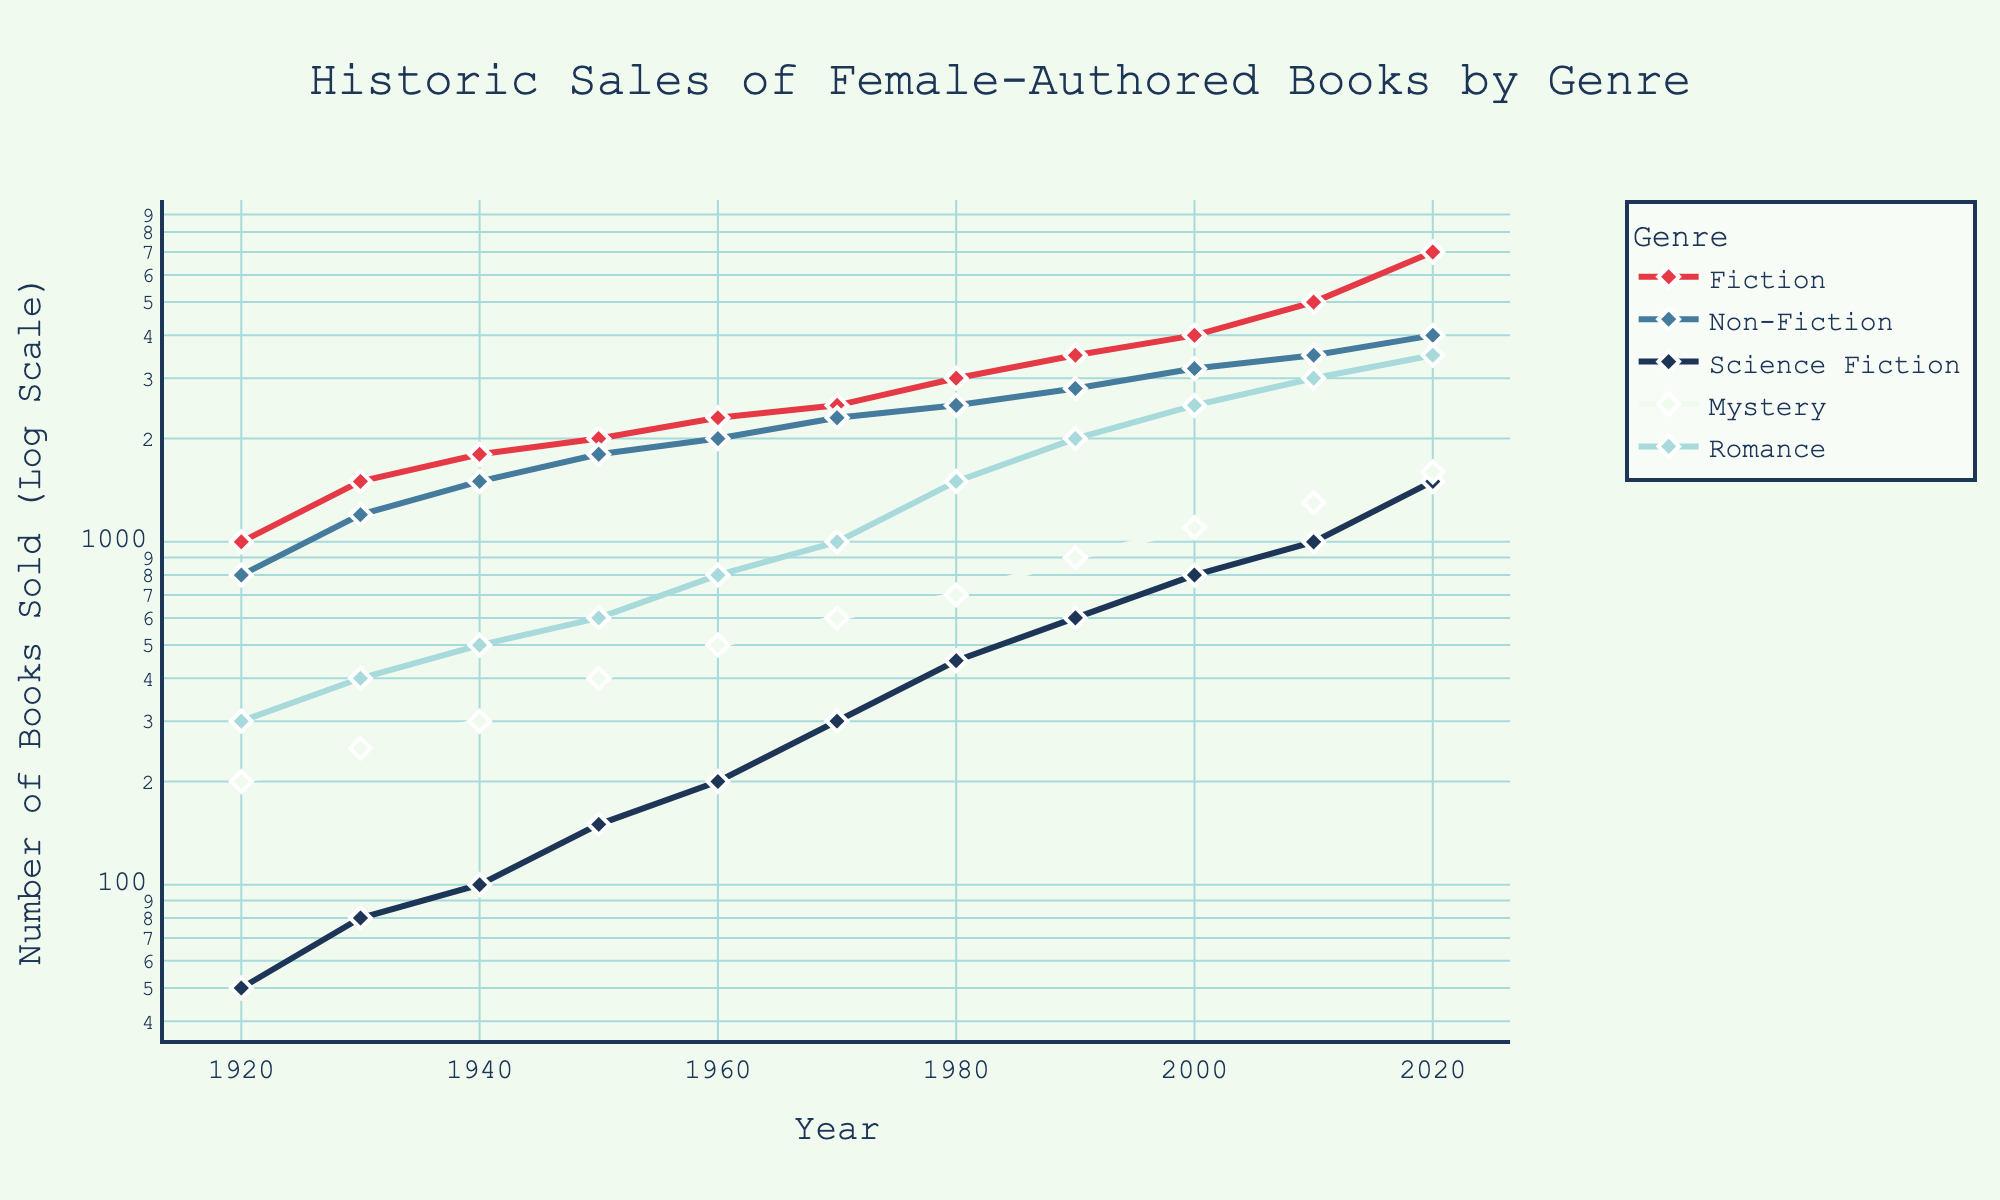what is the title of the plot? The title of the plot is displayed at the top center of the figure in larger text. From the provided code, the title is clearly stated in the layout update section.
Answer: Historic Sales of Female-Authored Books by Genre which genre shows the highest number of books sold in 2020? To find the highest number of books sold in 2020, look at the data points for each genre at the year 2020 along the y-axis. The genre with the highest y-value represents the highest sales.
Answer: Fiction how many genres are represented in the plot? The genres are listed next to each line and in the legend. Count the number of distinct genres mentioned.
Answer: 5 comparing 1950 and 2000, which genre saw the highest growth in sales? To determine the highest growth in sales, calculate the difference in the number of books sold for each genre between 1950 and 2000. The genre with the largest positive difference has the highest growth.
Answer: Romance what is the y-axis scale of the plot? The y-axis scale is indicated both visually by the spacing of the tick marks and confirmed by the code description. It is a logarithmic scale.
Answer: Logarithmic what are the y-values for Mystery and Non-Fiction genres in 1980? Find the points corresponding to the year 1980 for both Mystery and Non-Fiction genres along the y-axis. Note down their values.
Answer: 700 (Mystery), 2500 (Non-Fiction) why do the data points for Fiction stand out compared to other genres? Reviewing the entire plot, Fiction consistently has higher sales. Analyze how Fiction trends upward and stays above the rest.
Answer: Highest overall sales and clear upward trend are there any years where sales for Science Fiction spiked? Examine the line representing Science Fiction and note any years where there is a noticeable increase in the y-value. Look for significant jumps upwards.
Answer: 1970 and 2020 how does the trend of Romance sales compare to Non-Fiction over the century? Compare the lines representing Romance and Non-Fiction from 1920 to 2020. Check if they both increase, remain stable, or have fluctuations. Romance shows steady growth crossing Non-Fiction around 2000.
Answer: Initially lower, surpasses Non-Fiction after 2000 which genre showed the least variability in sales between 1920 and 2020? Look for the genre with the smallest fluctuations in its line over the years, suggesting more stable sales.
Answer: Non-Fiction 